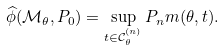Convert formula to latex. <formula><loc_0><loc_0><loc_500><loc_500>\widehat { \phi } ( \mathcal { M } _ { \theta } , P _ { 0 } ) = \sup _ { t \in \mathcal { C } _ { \theta } ^ { ( n ) } } P _ { n } m ( \theta , t ) .</formula> 